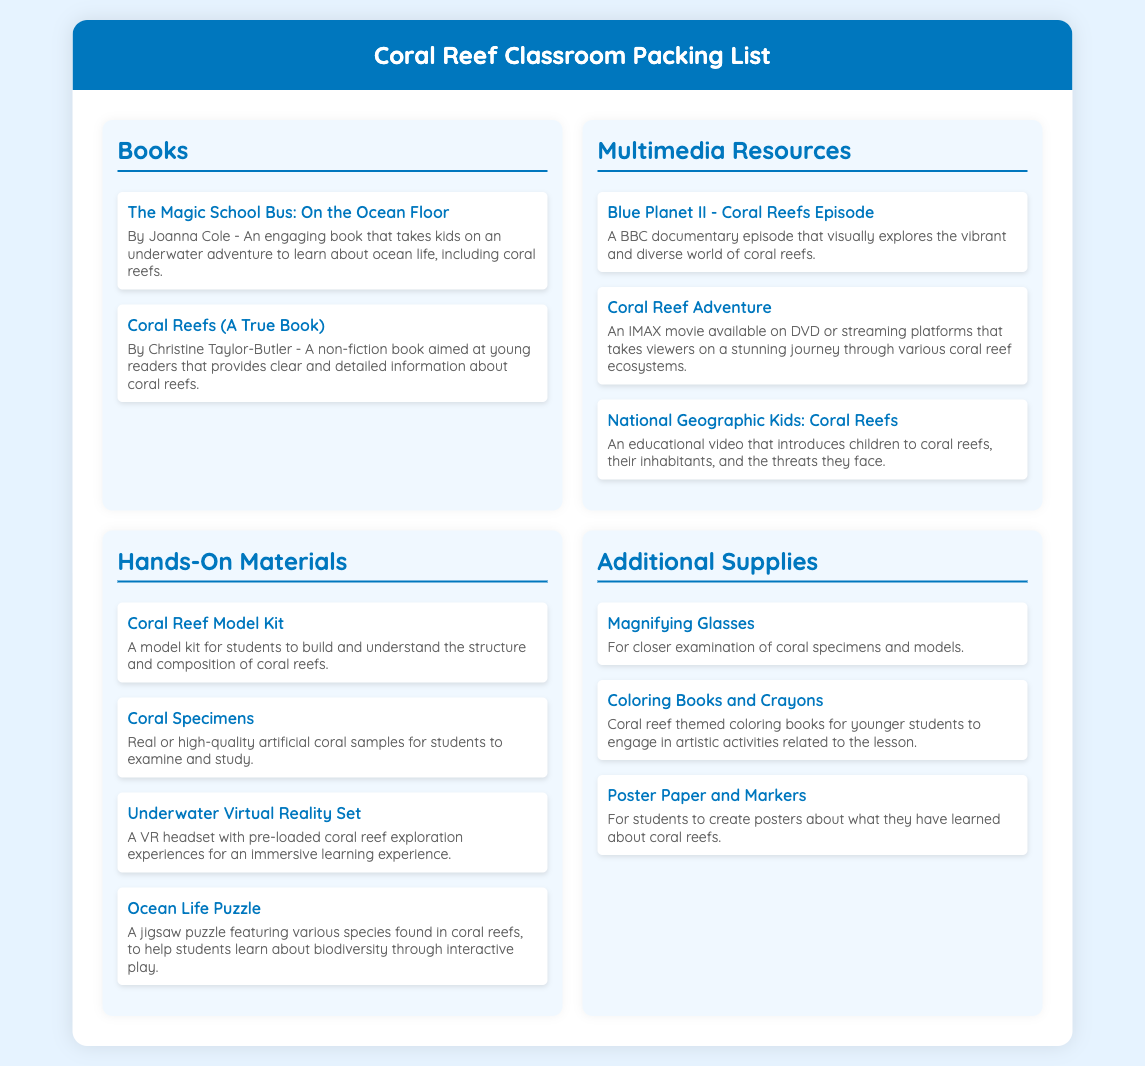what is the title of the first book listed? The title is mentioned in the "Books" section of the document.
Answer: The Magic School Bus: On the Ocean Floor how many multimedia resources are listed? The number of items can be found in the "Multimedia Resources" section.
Answer: Three what type of kit is mentioned in the hands-on materials? This refers to one specific item listed under "Hands-On Materials."
Answer: Coral Reef Model Kit which book is authored by Christine Taylor-Butler? This information is found in the "Books" section along with the author's name.
Answer: Coral Reefs (A True Book) what unique experience does the Underwater Virtual Reality Set provide? This is mentioned in the details of the corresponding item in the "Hands-On Materials" section.
Answer: Immersive learning experience is there a jigsaw puzzle included in the hands-on materials? This can be corroborated by looking at the "Hands-On Materials" section.
Answer: Yes what are the additional supplies mentioned? The section "Additional Supplies" details various items required beyond the main categories.
Answer: Magnifying Glasses, Coloring Books and Crayons, Poster Paper and Markers 